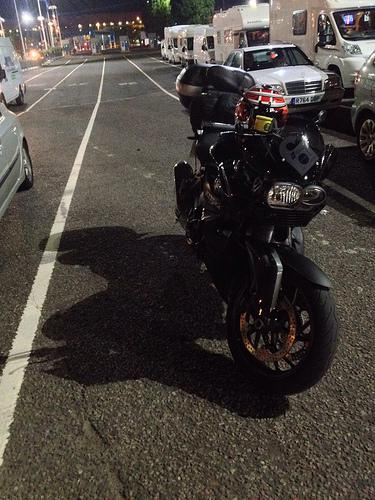Question: who is on the motorcycle?
Choices:
A. Man.
B. Woman.
C. Teenager.
D. Unoccupied.
Answer with the letter. Answer: D Question: where was the photo taken?
Choices:
A. The sidewalk.
B. The park.
C. The street.
D. The courtyard.
Answer with the letter. Answer: C Question: what time of day is it?
Choices:
A. Daytime.
B. Afternoon.
C. Sunset.
D. Night time.
Answer with the letter. Answer: D Question: how many motorcycles are there?
Choices:
A. Two.
B. Three.
C. One.
D. Four.
Answer with the letter. Answer: C Question: why is it so dark?
Choices:
A. It is night.
B. A storm.
C. Sun went down.
D. Blackout.
Answer with the letter. Answer: C 